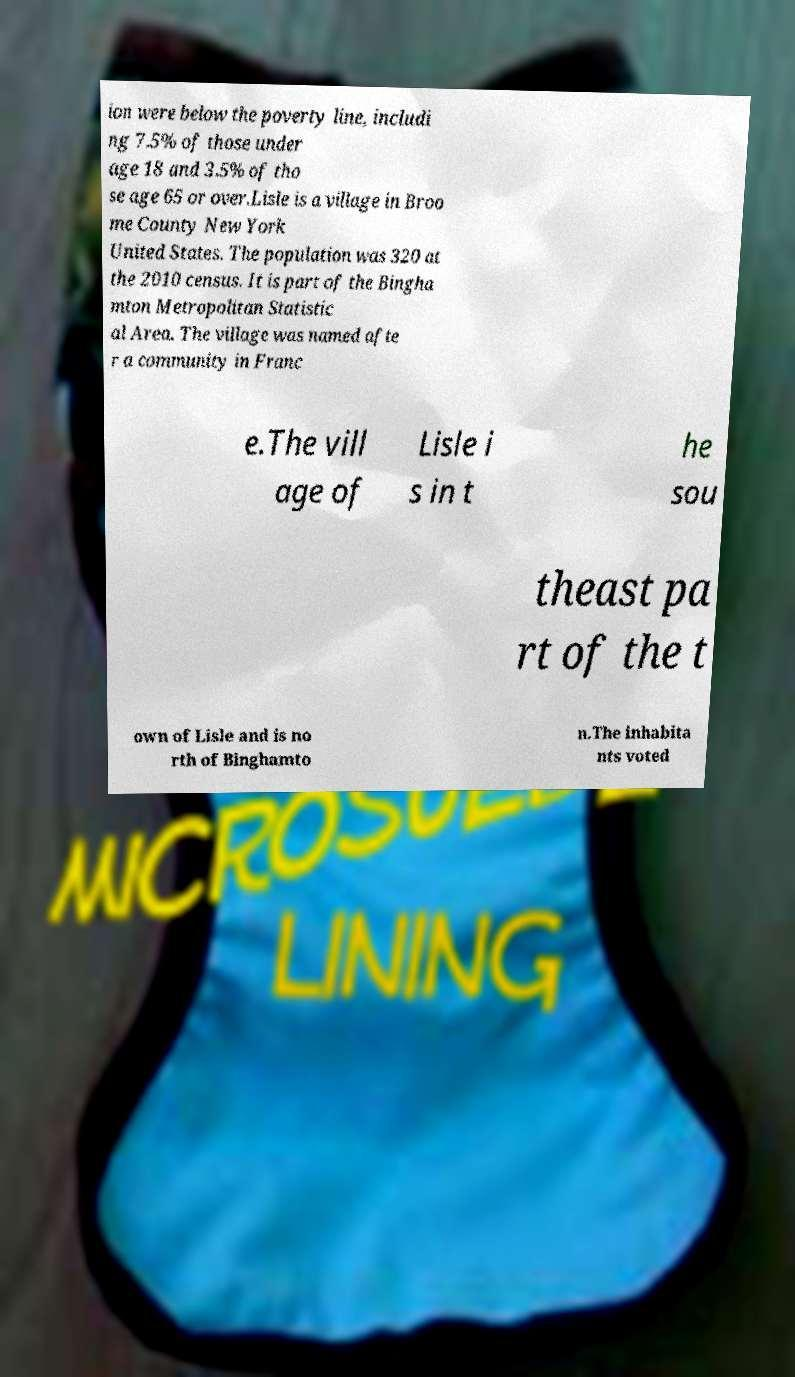What messages or text are displayed in this image? I need them in a readable, typed format. ion were below the poverty line, includi ng 7.5% of those under age 18 and 3.5% of tho se age 65 or over.Lisle is a village in Broo me County New York United States. The population was 320 at the 2010 census. It is part of the Bingha mton Metropolitan Statistic al Area. The village was named afte r a community in Franc e.The vill age of Lisle i s in t he sou theast pa rt of the t own of Lisle and is no rth of Binghamto n.The inhabita nts voted 